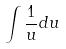Convert formula to latex. <formula><loc_0><loc_0><loc_500><loc_500>\int \frac { 1 } { u } d u</formula> 